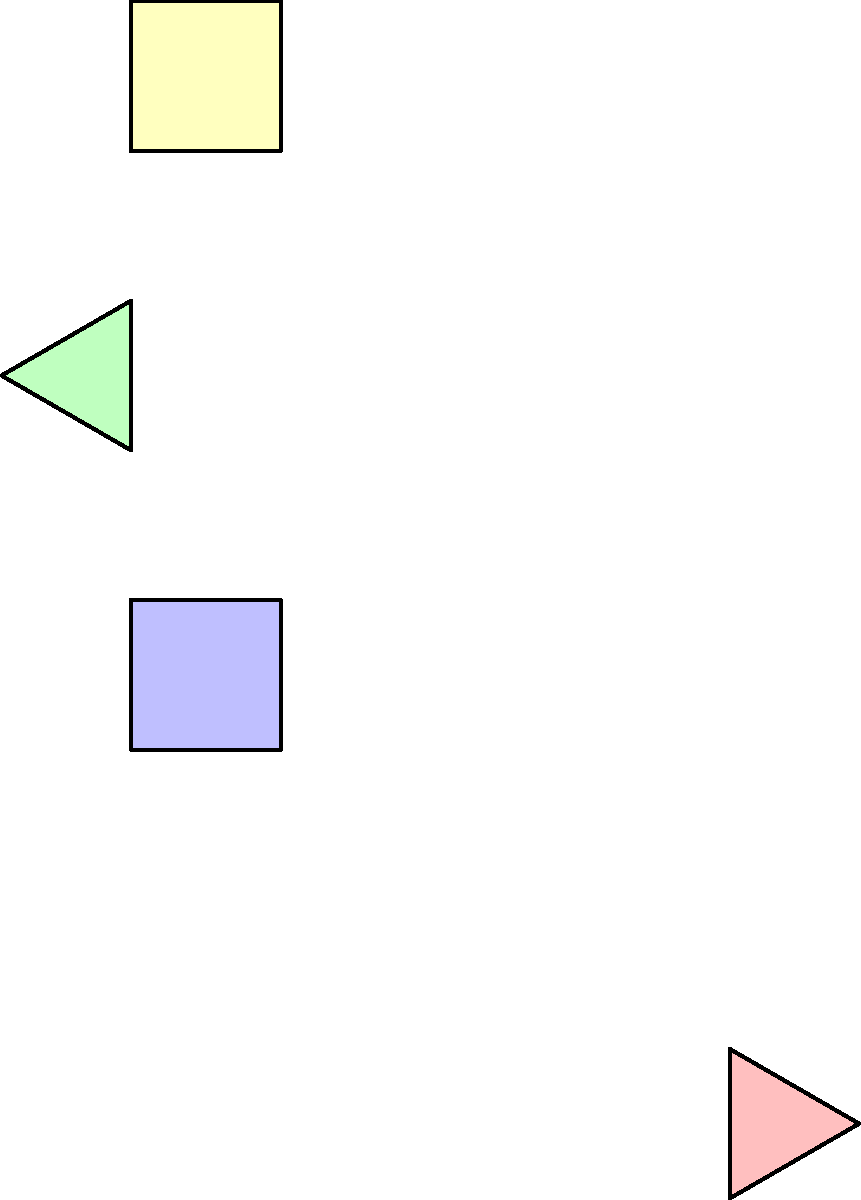In this interactive art project, we have four shapes: A, B, C, and D. Which of these shapes are congruent to each other, and what transformations (rotations or reflections) would you use to make them match? Let's analyze each shape step-by-step:

1. Shape A: A blue square
2. Shape B: A green triangle
3. Shape C: A yellow square
4. Shape D: A red triangle

To determine congruence and transformations:

1. Squares (A and C):
   - A and C are both squares of the same size.
   - C can be obtained from A by reflecting across the line $y=x$ and translating.
   - Therefore, A and C are congruent.

2. Triangles (B and D):
   - B and D are both equilateral triangles of the same size.
   - D can be obtained from B by rotating 180 degrees around the point (1,1).
   - Therefore, B and D are congruent.

3. Squares vs. Triangles:
   - The squares and triangles have different shapes, so they are not congruent to each other.

In summary, A is congruent to C (reflection and translation), and B is congruent to D (180-degree rotation).
Answer: A congruent to C; B congruent to D 